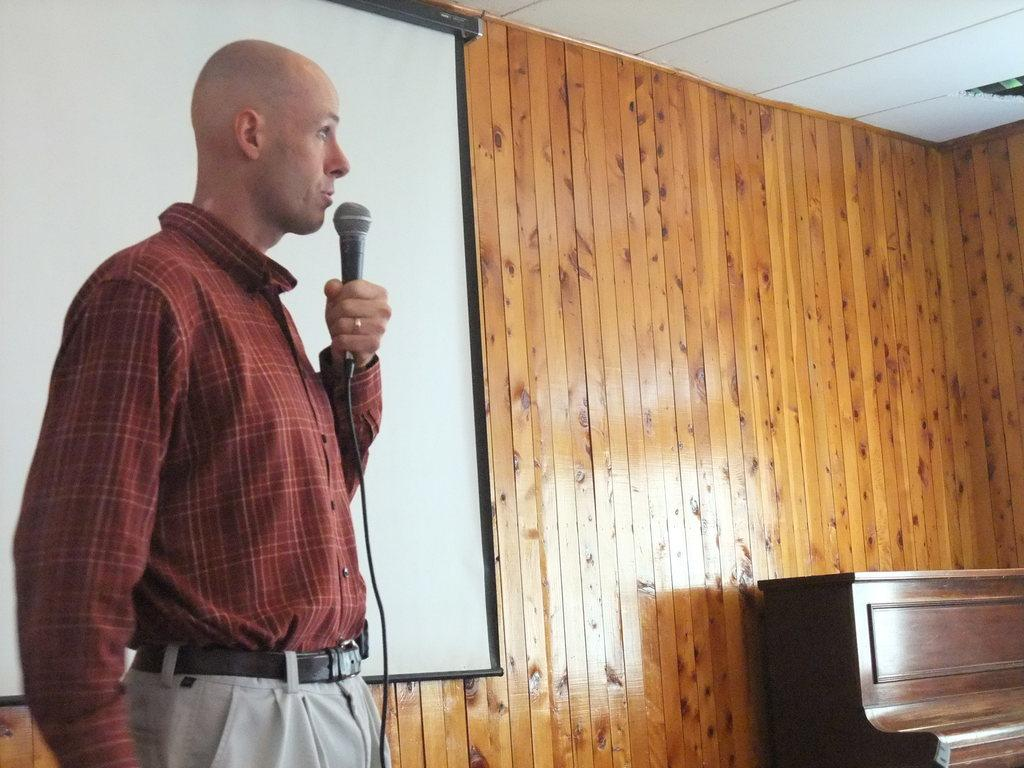What is the main object in the image? There is a screen in the image. Who is present in the image? A man is standing in the image. What is the man holding in the image? The man is holding a microphone. What type of organization is depicted on the screen in the image? There is no organization depicted on the screen in the image; it is a screen without any visible content. 